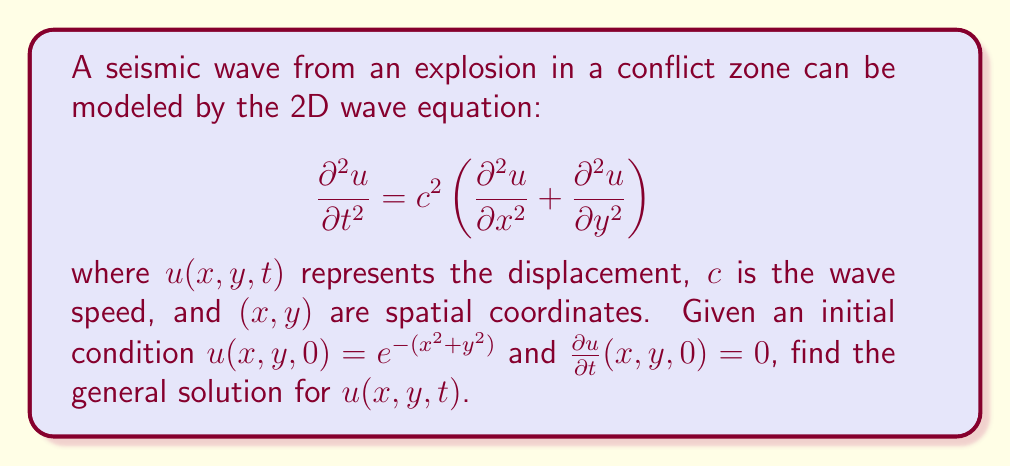What is the answer to this math problem? To solve this problem, we'll follow these steps:

1) The general solution to the 2D wave equation is given by d'Alembert's formula:

   $$u(x,y,t) = \frac{1}{2\pi} \int_0^{2\pi} f(x + ct\cos\theta, y + ct\sin\theta) d\theta$$

   where $f(x,y)$ is the initial condition.

2) In our case, $f(x,y) = e^{-(x^2+y^2)}$.

3) Substituting this into d'Alembert's formula:

   $$u(x,y,t) = \frac{1}{2\pi} \int_0^{2\pi} e^{-((x+ct\cos\theta)^2 + (y+ct\sin\theta)^2)} d\theta$$

4) Expanding the exponent:

   $$u(x,y,t) = \frac{1}{2\pi} \int_0^{2\pi} e^{-(x^2+y^2+c^2t^2+2ct(x\cos\theta+y\sin\theta))} d\theta$$

5) We can factor out the terms that don't depend on $\theta$:

   $$u(x,y,t) = e^{-(x^2+y^2+c^2t^2)} \frac{1}{2\pi} \int_0^{2\pi} e^{-2ct(x\cos\theta+y\sin\theta)} d\theta$$

6) The remaining integral is a modified Bessel function of the first kind:

   $$\frac{1}{2\pi} \int_0^{2\pi} e^{-2ct(x\cos\theta+y\sin\theta)} d\theta = I_0(2ct\sqrt{x^2+y^2})$$

7) Therefore, the general solution is:

   $$u(x,y,t) = e^{-(x^2+y^2+c^2t^2)} I_0(2ct\sqrt{x^2+y^2})$$

This solution represents a circular wave propagating outward from the origin, with amplitude decreasing over time and distance.
Answer: $u(x,y,t) = e^{-(x^2+y^2+c^2t^2)} I_0(2ct\sqrt{x^2+y^2})$ 